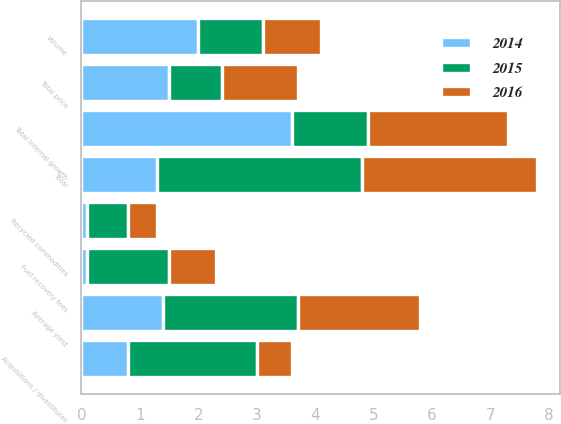Convert chart. <chart><loc_0><loc_0><loc_500><loc_500><stacked_bar_chart><ecel><fcel>Average yield<fcel>Fuel recovery fees<fcel>Total price<fcel>Volume<fcel>Recycled commodities<fcel>Total internal growth<fcel>Acquisitions / divestitures<fcel>Total<nl><fcel>2016<fcel>2.1<fcel>0.8<fcel>1.3<fcel>1<fcel>0.5<fcel>2.4<fcel>0.6<fcel>3<nl><fcel>2015<fcel>2.3<fcel>1.4<fcel>0.9<fcel>1.1<fcel>0.7<fcel>1.3<fcel>2.2<fcel>3.5<nl><fcel>2014<fcel>1.4<fcel>0.1<fcel>1.5<fcel>2<fcel>0.1<fcel>3.6<fcel>0.8<fcel>1.3<nl></chart> 